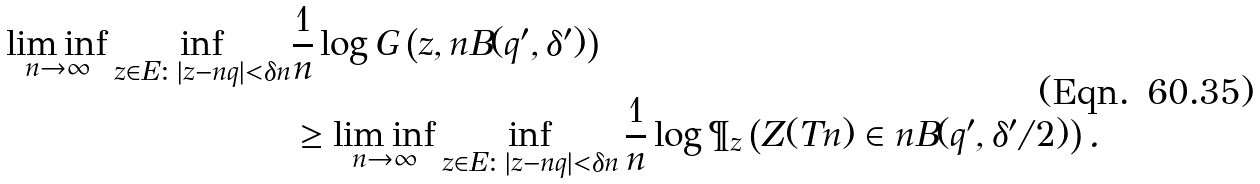<formula> <loc_0><loc_0><loc_500><loc_500>\liminf _ { n \to \infty } \inf _ { z \in E \colon | z - n q | < \delta n } & \frac { 1 } { n } \log G \left ( z , n B ( q ^ { \prime } , \delta ^ { \prime } ) \right ) \\ & \geq \liminf _ { n \to \infty } \inf _ { z \in E \colon | z - n q | < \delta n } \frac { 1 } { n } \log \P _ { z } \left ( Z ( T n ) \in n B ( q ^ { \prime } , \delta ^ { \prime } / 2 ) \right ) .</formula> 